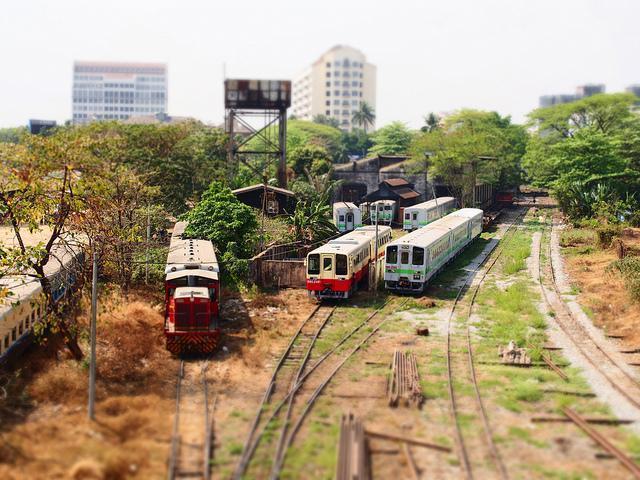How many sets of train tracks can you see?
Give a very brief answer. 5. How many trains are there?
Give a very brief answer. 4. 